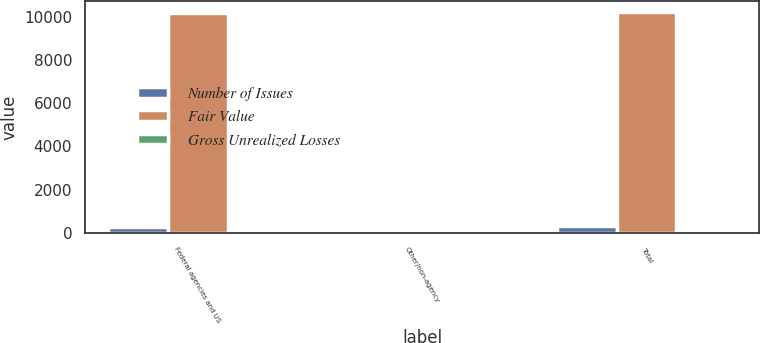Convert chart. <chart><loc_0><loc_0><loc_500><loc_500><stacked_bar_chart><ecel><fcel>Federal agencies and US<fcel>Other/non-agency<fcel>Total<nl><fcel>Number of Issues<fcel>294<fcel>6<fcel>300<nl><fcel>Fair Value<fcel>10163<fcel>55<fcel>10218<nl><fcel>Gross Unrealized Losses<fcel>97<fcel>1<fcel>98<nl></chart> 